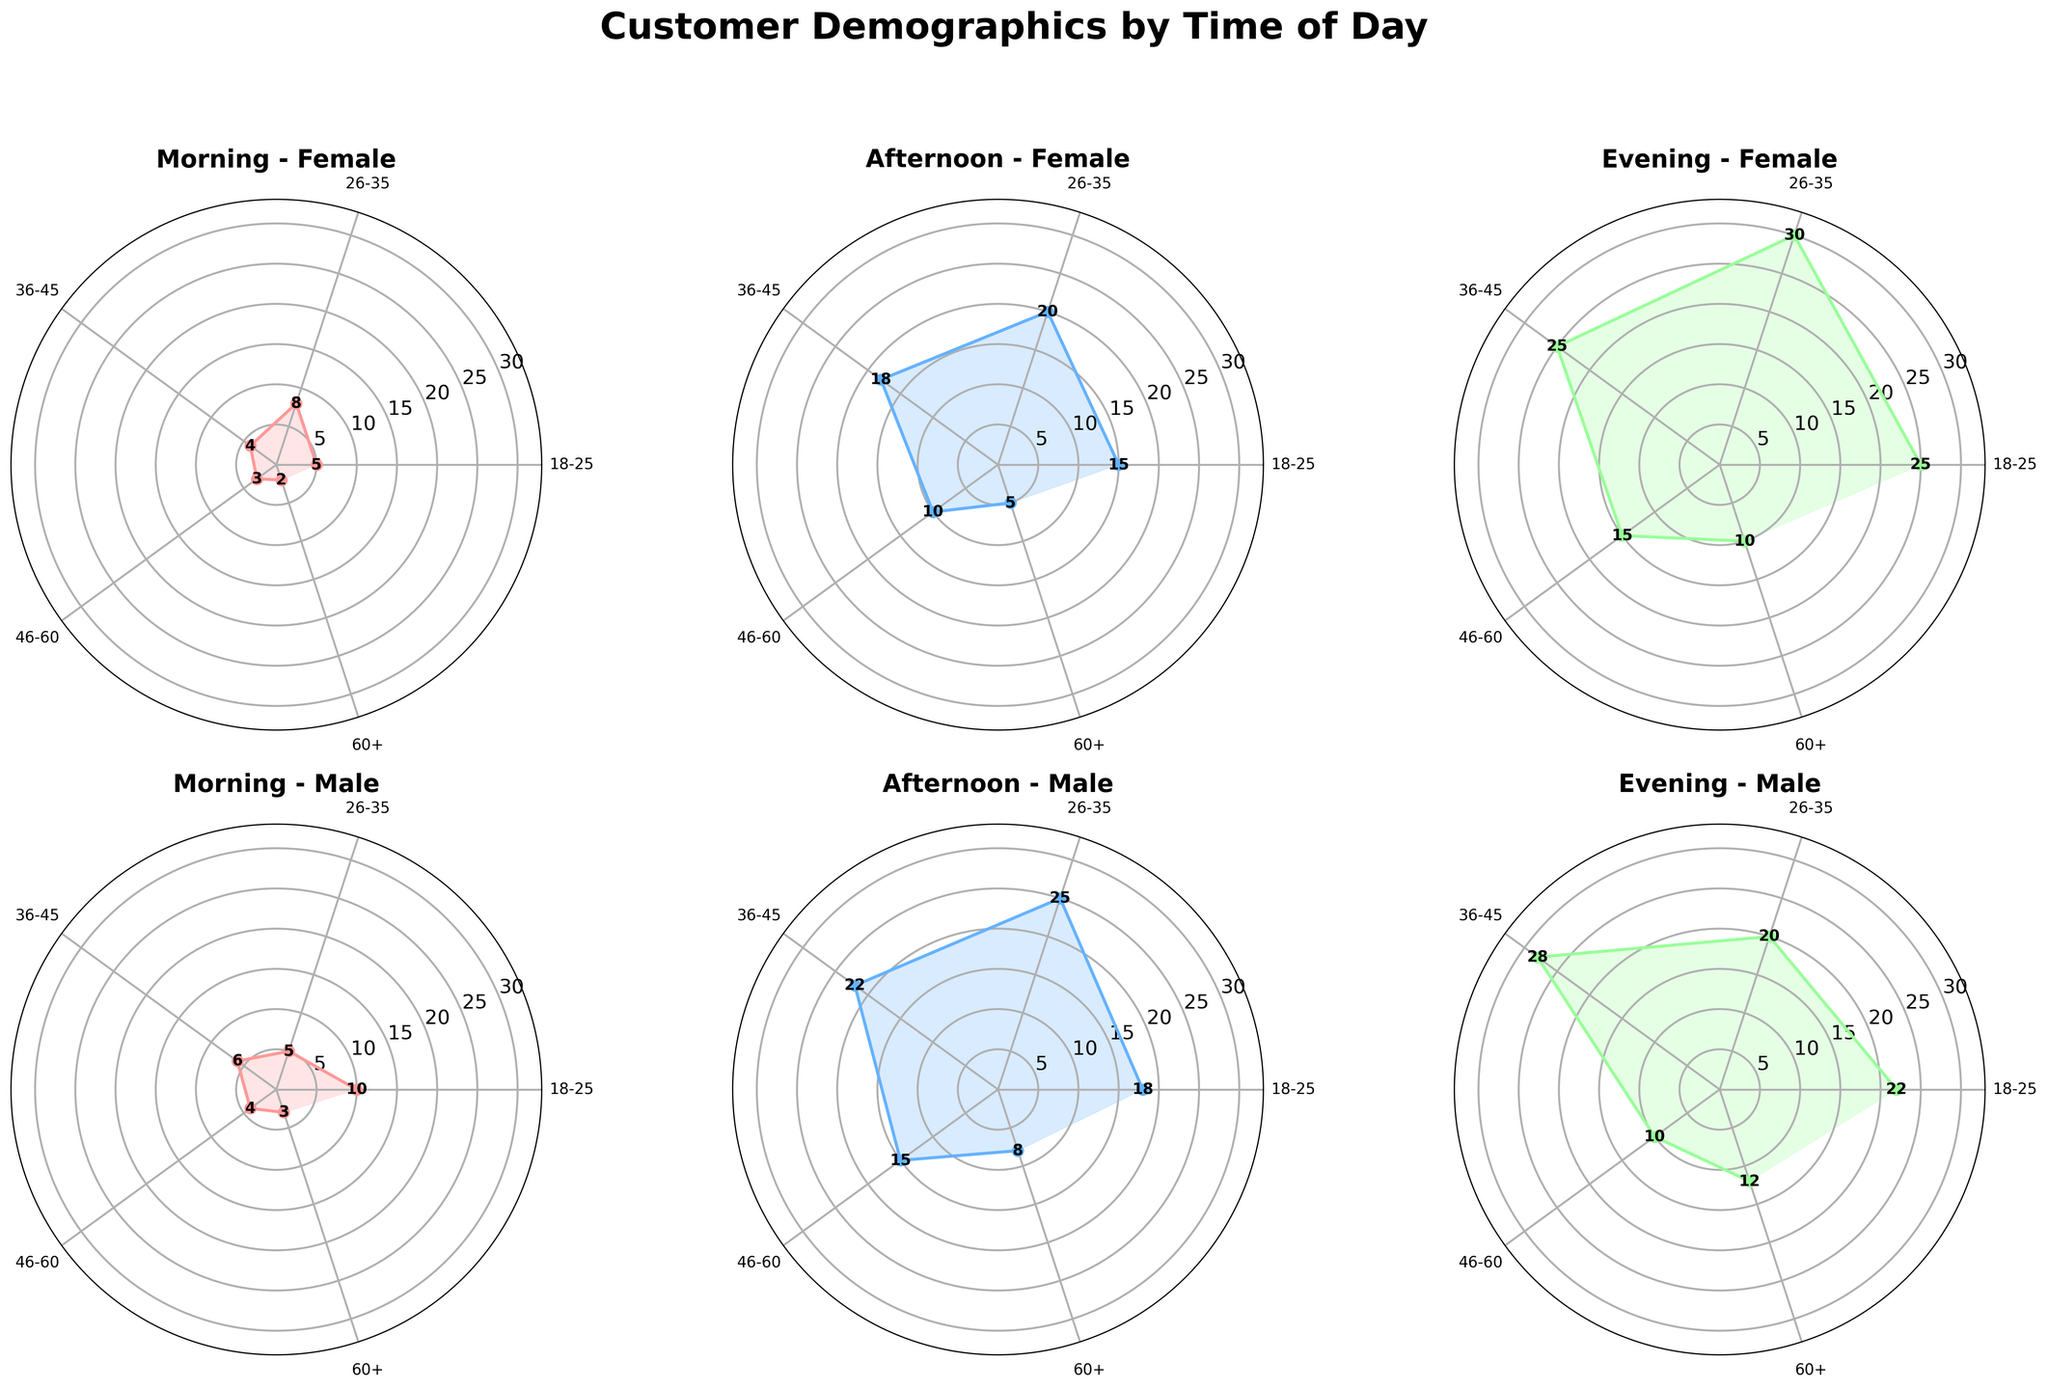What is the title of the overall figure? The title of a figure is usually positioned at the top. In this case, the title is prominently displayed in bold, large font.
Answer: "Customer Demographics by Time of Day" What age group has the highest number of female students in the evening? By looking at the Evening-Female plot, the age group with the highest value for females labeled as students can be observed.
Answer: 18-25 During the afternoon, which gender has a higher number of customers in the age group 26-35? To determine this, compare the values for both male and female in the 26-35 age group in the Afternoon-Female and Afternoon-Male plots. For females, it is 20, and for males, it is 25.
Answer: Male Which time period has the lowest number of female customers aged 60+? Check the Female plots for Morning, Afternoon, and Evening. Compare the values for the 60+ age group across these times. The values are 2, 5, and 10 respectively.
Answer: Morning Compare the number of male retired customers aged 46-60 between morning and evening. Examine the relevant plots. In the Morning-Male plot, the value for 46-60 is 4. In the Evening-Male plot, the value for the same group is 10. The difference is 10 - 4.
Answer: 6 Which occupation has more female customers in the evening for the 36-45 age group? In the Evening-Female plot, observe the value for the 36-45 age group. Since it can only be Professional (25), comparison is not needed.
Answer: Professional What is the total number of male customers aged 18-25 across all time periods? Sum the values for the 18-25 age group in the Morning, Afternoon, and Evening-Male plots. The values are 10, 18, and 22 respectively. 10 + 18 + 22 = 50
Answer: 50 How many more female students are there in the evening compared to the morning? Look at the Female plots. The evening value is 25, and the morning value is 5. The difference is calculated as 25 - 5.
Answer: 20 For professional males aged 26-35, which time of day shows the most visits? In the Male plots, compare the values for the 26-35 age group across different times: Morning (5), Afternoon (25), and Evening (20). The highest value is in the afternoon.
Answer: Afternoon How do the counts of retired males aged 60+ change from morning to evening? Refer to the Morning-Male and Evening-Male plots. For the 60+ age group, the values are 3 and 12 respectively. The change is computed as 12 - 3.
Answer: 9 